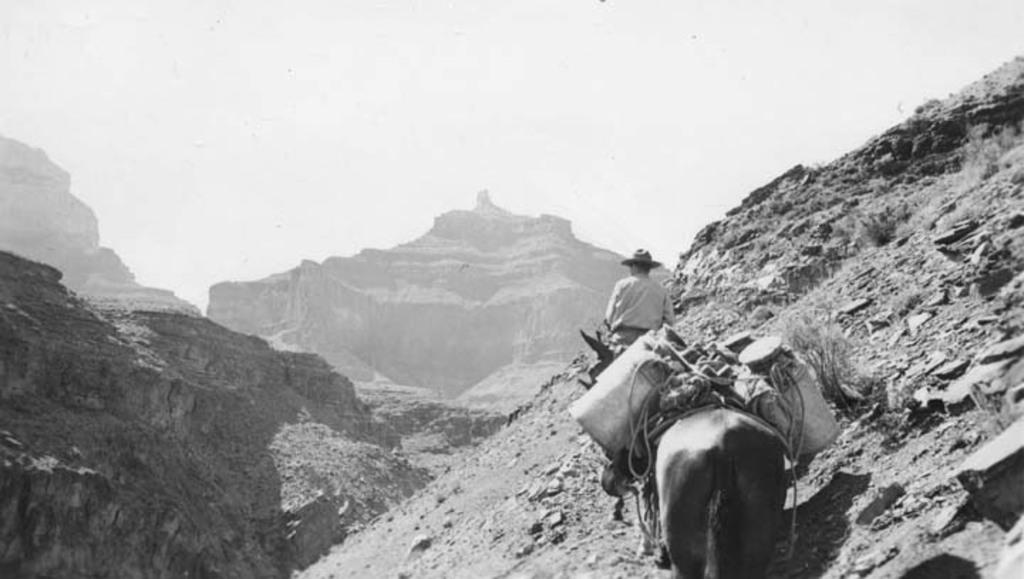What is the color scheme of the image? The image is black and white. What is the main subject of the image? There is a man on a horse in the image. Are there any other people in the image? Yes, there is another man in the image. What objects can be seen in the image? There are cans in the image. What type of landscape is visible in the image? There are mountains visible in the image. What else can be seen in the sky? The sky is visible in the image. What type of board is the man on the horse using in the image? There is no board present in the image; the man is simply riding a horse. What kind of system is responsible for the horse's movement in the image? The horse's movement is not attributed to any system in the image; it is a living creature that moves naturally. 